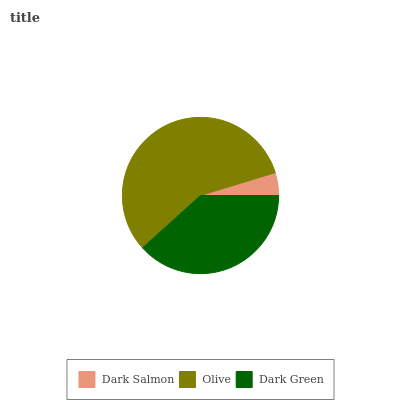Is Dark Salmon the minimum?
Answer yes or no. Yes. Is Olive the maximum?
Answer yes or no. Yes. Is Dark Green the minimum?
Answer yes or no. No. Is Dark Green the maximum?
Answer yes or no. No. Is Olive greater than Dark Green?
Answer yes or no. Yes. Is Dark Green less than Olive?
Answer yes or no. Yes. Is Dark Green greater than Olive?
Answer yes or no. No. Is Olive less than Dark Green?
Answer yes or no. No. Is Dark Green the high median?
Answer yes or no. Yes. Is Dark Green the low median?
Answer yes or no. Yes. Is Dark Salmon the high median?
Answer yes or no. No. Is Olive the low median?
Answer yes or no. No. 